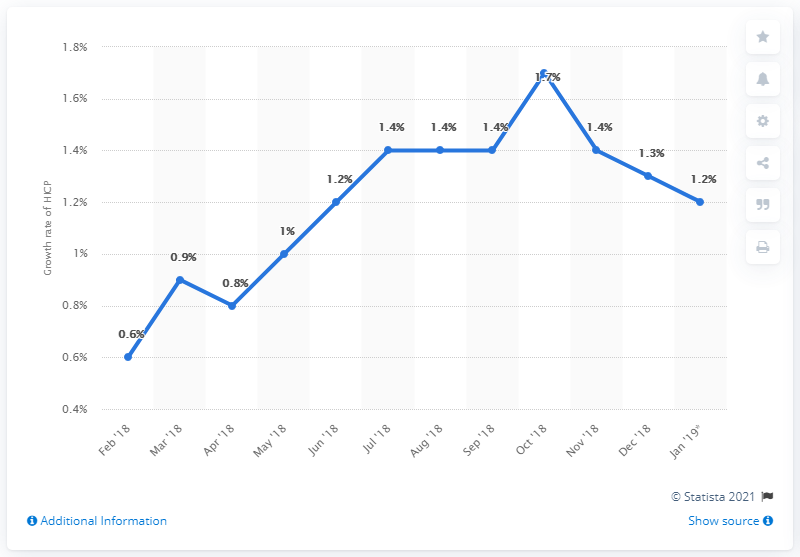List a handful of essential elements in this visual. In May 2018, the growth rate was 1%. The sum of mode and least rate is 2. The inflation rate in December 2018 was 1.3%. 